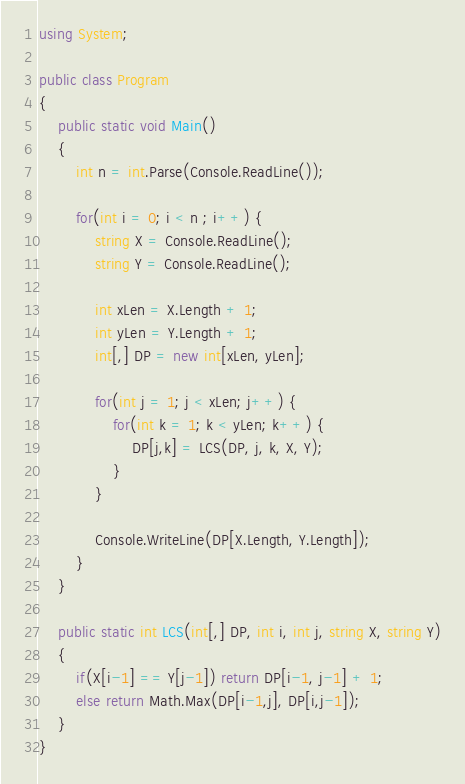Convert code to text. <code><loc_0><loc_0><loc_500><loc_500><_C#_>using System;
					
public class Program
{	
	public static void Main()
	{
		int n = int.Parse(Console.ReadLine());
		
		for(int i = 0; i < n ; i++) {
			string X = Console.ReadLine();
			string Y = Console.ReadLine();
			
			int xLen = X.Length + 1;
			int yLen = Y.Length + 1;
			int[,] DP = new int[xLen, yLen];
			
			for(int j = 1; j < xLen; j++) {
				for(int k = 1; k < yLen; k++) {
					DP[j,k] = LCS(DP, j, k, X, Y);
				}
			}
			
			Console.WriteLine(DP[X.Length, Y.Length]);
		}
	}
	
	public static int LCS(int[,] DP, int i, int j, string X, string Y)
	{
		if(X[i-1] == Y[j-1]) return DP[i-1, j-1] + 1;
		else return Math.Max(DP[i-1,j], DP[i,j-1]);
	}
}</code> 